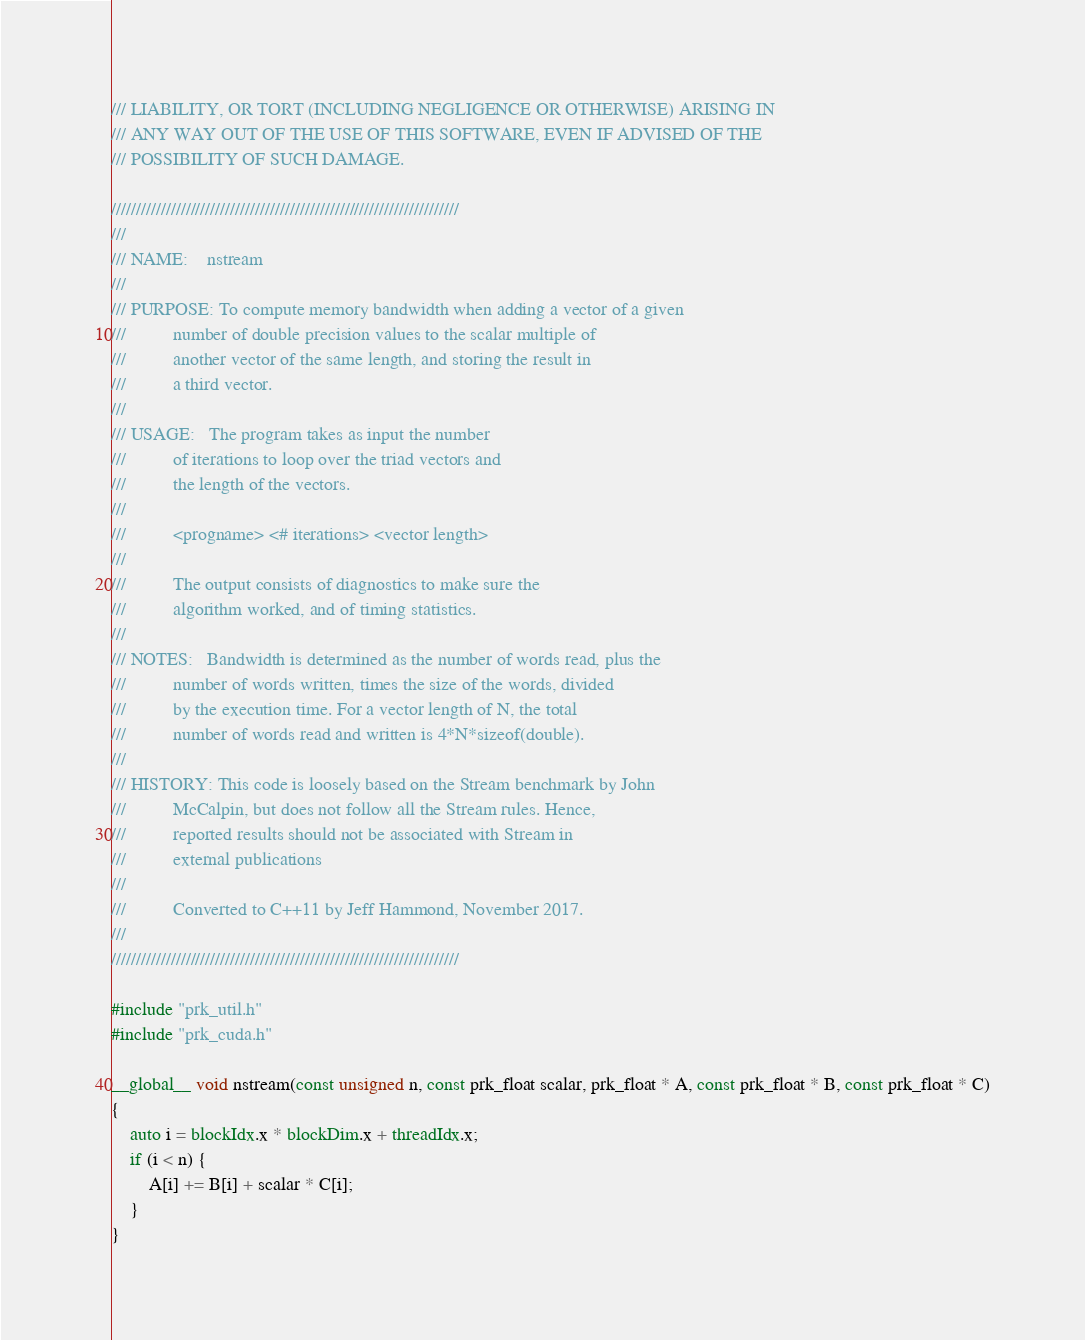<code> <loc_0><loc_0><loc_500><loc_500><_Cuda_>/// LIABILITY, OR TORT (INCLUDING NEGLIGENCE OR OTHERWISE) ARISING IN
/// ANY WAY OUT OF THE USE OF THIS SOFTWARE, EVEN IF ADVISED OF THE
/// POSSIBILITY OF SUCH DAMAGE.

//////////////////////////////////////////////////////////////////////
///
/// NAME:    nstream
///
/// PURPOSE: To compute memory bandwidth when adding a vector of a given
///          number of double precision values to the scalar multiple of
///          another vector of the same length, and storing the result in
///          a third vector.
///
/// USAGE:   The program takes as input the number
///          of iterations to loop over the triad vectors and
///          the length of the vectors.
///
///          <progname> <# iterations> <vector length>
///
///          The output consists of diagnostics to make sure the
///          algorithm worked, and of timing statistics.
///
/// NOTES:   Bandwidth is determined as the number of words read, plus the
///          number of words written, times the size of the words, divided
///          by the execution time. For a vector length of N, the total
///          number of words read and written is 4*N*sizeof(double).
///
/// HISTORY: This code is loosely based on the Stream benchmark by John
///          McCalpin, but does not follow all the Stream rules. Hence,
///          reported results should not be associated with Stream in
///          external publications
///
///          Converted to C++11 by Jeff Hammond, November 2017.
///
//////////////////////////////////////////////////////////////////////

#include "prk_util.h"
#include "prk_cuda.h"

__global__ void nstream(const unsigned n, const prk_float scalar, prk_float * A, const prk_float * B, const prk_float * C)
{
    auto i = blockIdx.x * blockDim.x + threadIdx.x;
    if (i < n) {
        A[i] += B[i] + scalar * C[i];
    }
}
</code> 